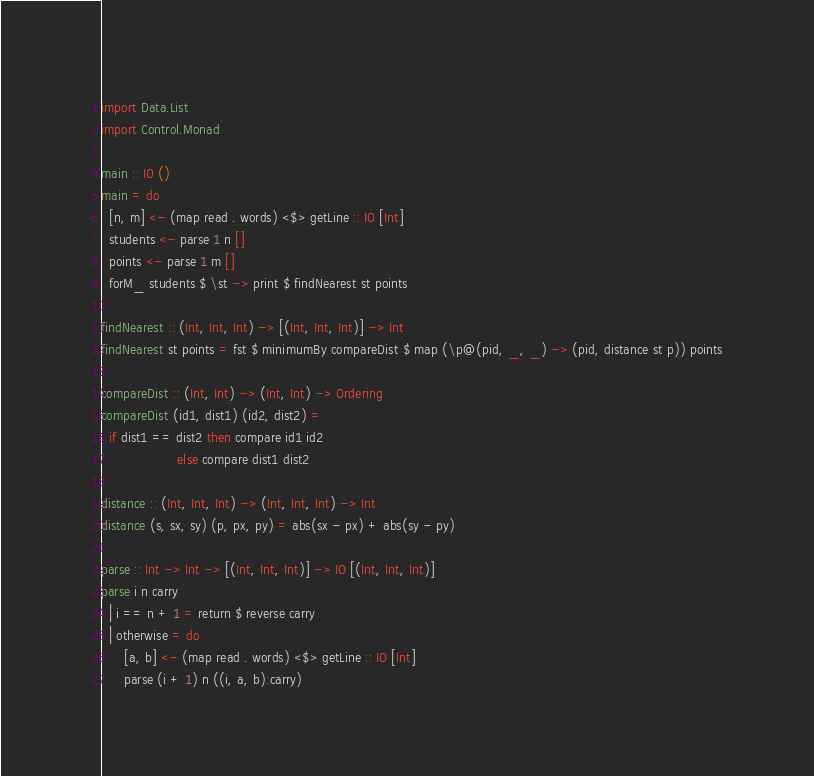Convert code to text. <code><loc_0><loc_0><loc_500><loc_500><_Haskell_>import Data.List
import Control.Monad

main :: IO ()
main = do
  [n, m] <- (map read . words) <$> getLine :: IO [Int]
  students <- parse 1 n []
  points <- parse 1 m []
  forM_ students $ \st -> print $ findNearest st points

findNearest :: (Int, Int, Int) -> [(Int, Int, Int)] -> Int
findNearest st points = fst $ minimumBy compareDist $ map (\p@(pid, _, _) -> (pid, distance st p)) points

compareDist :: (Int, Int) -> (Int, Int) -> Ordering
compareDist (id1, dist1) (id2, dist2) =
  if dist1 == dist2 then compare id1 id2
                    else compare dist1 dist2

distance :: (Int, Int, Int) -> (Int, Int, Int) -> Int
distance (s, sx, sy) (p, px, py) = abs(sx - px) + abs(sy - py)

parse :: Int -> Int -> [(Int, Int, Int)] -> IO [(Int, Int, Int)]
parse i n carry
  | i == n + 1 = return $ reverse carry
  | otherwise = do
      [a, b] <- (map read . words) <$> getLine :: IO [Int]
      parse (i + 1) n ((i, a, b):carry)
</code> 